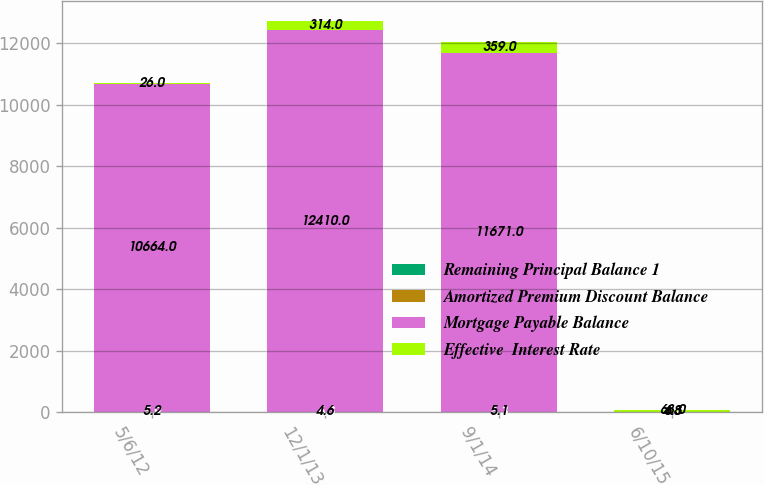<chart> <loc_0><loc_0><loc_500><loc_500><stacked_bar_chart><ecel><fcel>5/6/12<fcel>12/1/13<fcel>9/1/14<fcel>6/10/15<nl><fcel>Remaining Principal Balance 1<fcel>5.9<fcel>6.3<fcel>6.3<fcel>4.7<nl><fcel>Amortized Premium Discount Balance<fcel>5.2<fcel>4.6<fcel>5.1<fcel>4.8<nl><fcel>Mortgage Payable Balance<fcel>10664<fcel>12410<fcel>11671<fcel>6.3<nl><fcel>Effective  Interest Rate<fcel>26<fcel>314<fcel>359<fcel>68<nl></chart> 